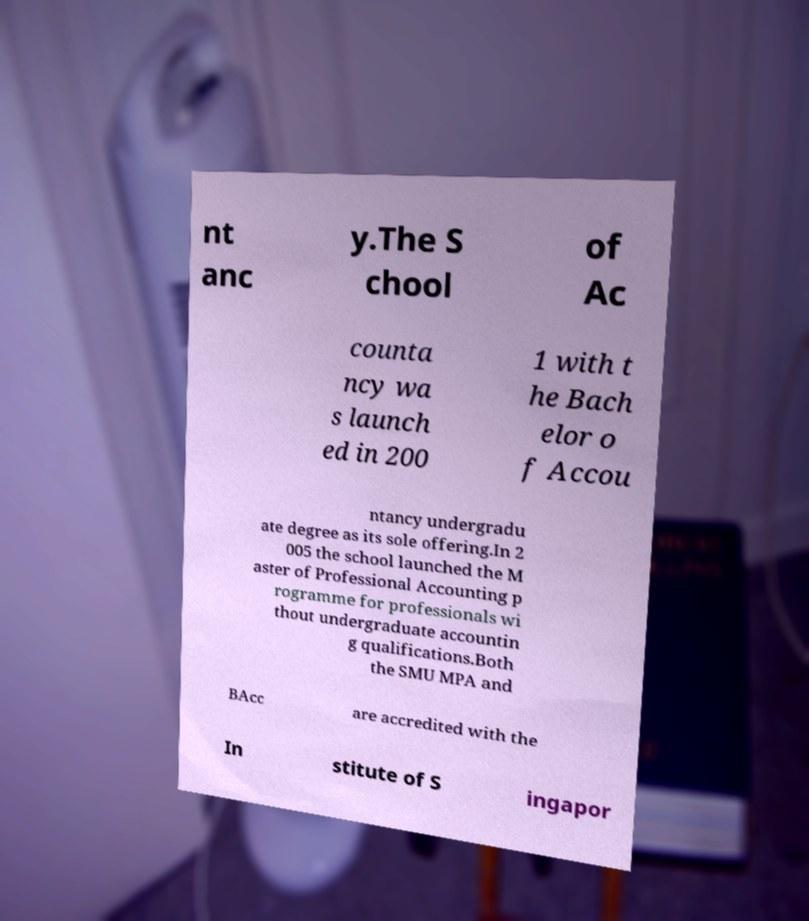What messages or text are displayed in this image? I need them in a readable, typed format. nt anc y.The S chool of Ac counta ncy wa s launch ed in 200 1 with t he Bach elor o f Accou ntancy undergradu ate degree as its sole offering.In 2 005 the school launched the M aster of Professional Accounting p rogramme for professionals wi thout undergraduate accountin g qualifications.Both the SMU MPA and BAcc are accredited with the In stitute of S ingapor 